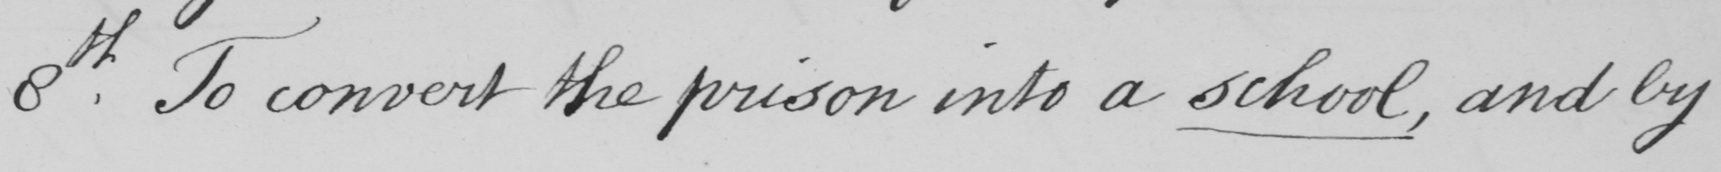Can you tell me what this handwritten text says? 8th . To conver the prison into a school , and by 